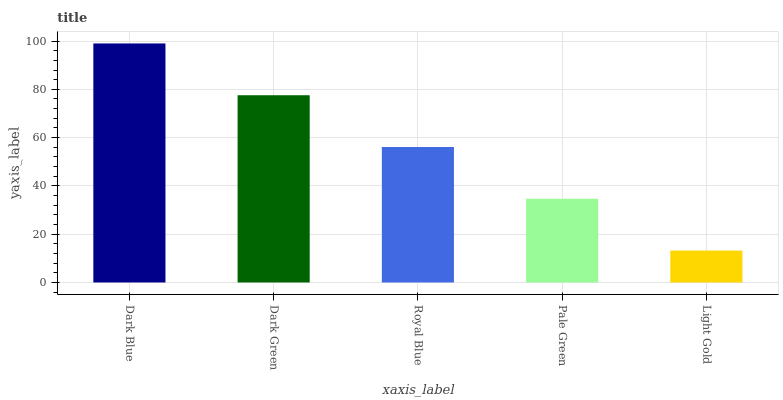Is Dark Green the minimum?
Answer yes or no. No. Is Dark Green the maximum?
Answer yes or no. No. Is Dark Blue greater than Dark Green?
Answer yes or no. Yes. Is Dark Green less than Dark Blue?
Answer yes or no. Yes. Is Dark Green greater than Dark Blue?
Answer yes or no. No. Is Dark Blue less than Dark Green?
Answer yes or no. No. Is Royal Blue the high median?
Answer yes or no. Yes. Is Royal Blue the low median?
Answer yes or no. Yes. Is Pale Green the high median?
Answer yes or no. No. Is Dark Blue the low median?
Answer yes or no. No. 